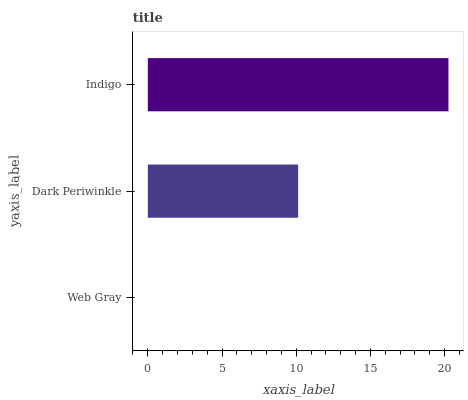Is Web Gray the minimum?
Answer yes or no. Yes. Is Indigo the maximum?
Answer yes or no. Yes. Is Dark Periwinkle the minimum?
Answer yes or no. No. Is Dark Periwinkle the maximum?
Answer yes or no. No. Is Dark Periwinkle greater than Web Gray?
Answer yes or no. Yes. Is Web Gray less than Dark Periwinkle?
Answer yes or no. Yes. Is Web Gray greater than Dark Periwinkle?
Answer yes or no. No. Is Dark Periwinkle less than Web Gray?
Answer yes or no. No. Is Dark Periwinkle the high median?
Answer yes or no. Yes. Is Dark Periwinkle the low median?
Answer yes or no. Yes. Is Indigo the high median?
Answer yes or no. No. Is Indigo the low median?
Answer yes or no. No. 